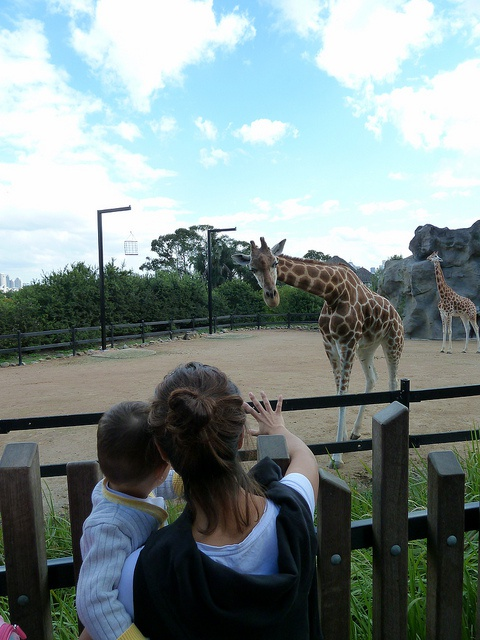Describe the objects in this image and their specific colors. I can see people in lightblue, black, gray, and darkgray tones, people in lightblue, black, and gray tones, giraffe in lightblue, gray, black, and darkgray tones, and giraffe in lightblue, gray, darkgray, and black tones in this image. 